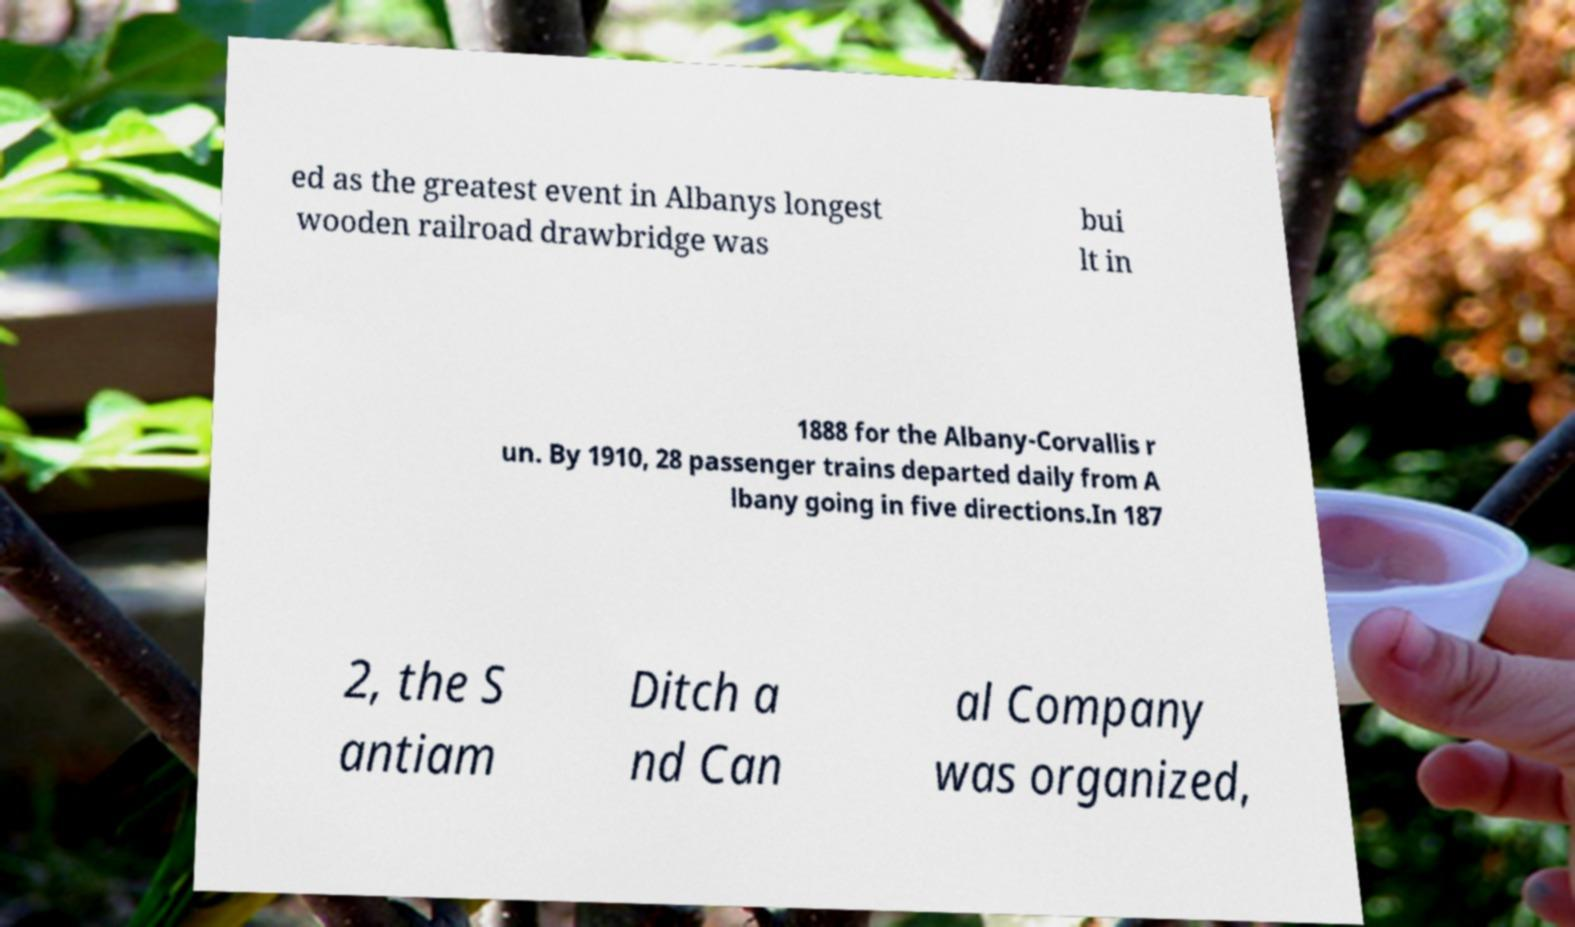For documentation purposes, I need the text within this image transcribed. Could you provide that? ed as the greatest event in Albanys longest wooden railroad drawbridge was bui lt in 1888 for the Albany-Corvallis r un. By 1910, 28 passenger trains departed daily from A lbany going in five directions.In 187 2, the S antiam Ditch a nd Can al Company was organized, 